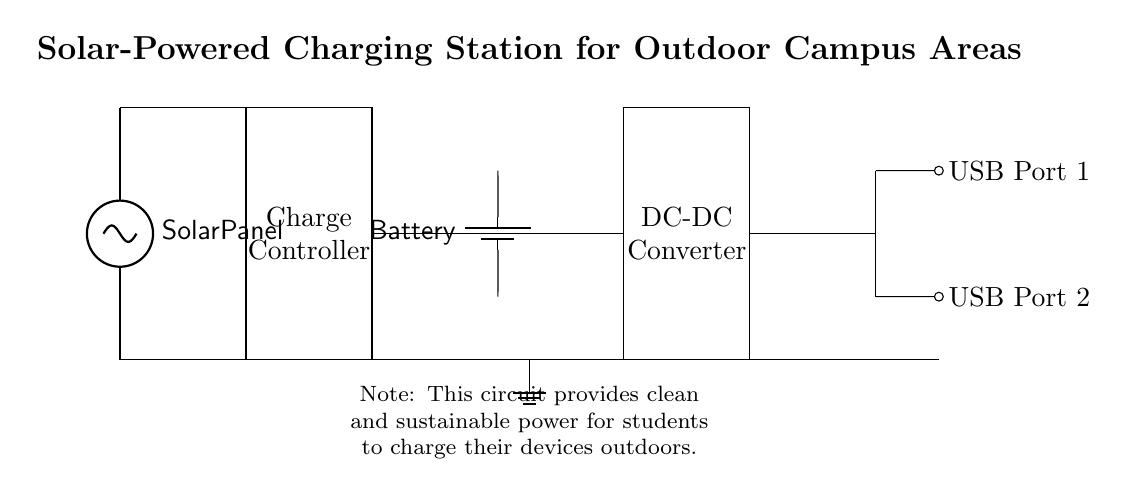What is the main component generating power in this circuit? The main component generating power is the solar panel, indicated at the start of the circuit. It is labeled as the source of energy that converts sunlight into electricity.
Answer: Solar Panel How many USB ports are available for charging? There are two USB ports shown in the diagram for charging devices. Each port is separately identified and labeled on the right side of the circuit.
Answer: Two What does the charge controller do in this circuit? The charge controller is responsible for managing the power flow from the solar panel to the battery, preventing overcharging and ensuring optimal battery performance. It is crucial for protecting the battery and ensuring efficient energy use.
Answer: Manage power flow What is the purpose of the DC-DC converter? The DC-DC converter transforms the voltage from the battery to a suitable level for charging devices via USB ports, ensuring that the correct voltage is supplied consistently. This is essential for the reliability of the charging station.
Answer: Convert voltage What type of power does the battery store? The battery stores direct current (DC) power, which comes from the solar panel after being processed by the charge controller. This stored energy is used to provide power to the USB charging ports when the solar panel output is insufficient.
Answer: Direct current How is the ground connection depicted in the circuit? The ground connection is depicted with a ground symbol located near the battery, indicating a reference point for the circuit’s electrical potential. It serves as a common return path for electric current, essential for circuit stability.
Answer: Ground symbol What does the note below the circuit indicate? The note beneath the circuit highlights that the system is designed to provide clean and sustainable power for outdoor charging purposes, emphasizing its environmental benefits for students who need to charge their devices outside.
Answer: Clean and sustainable power 